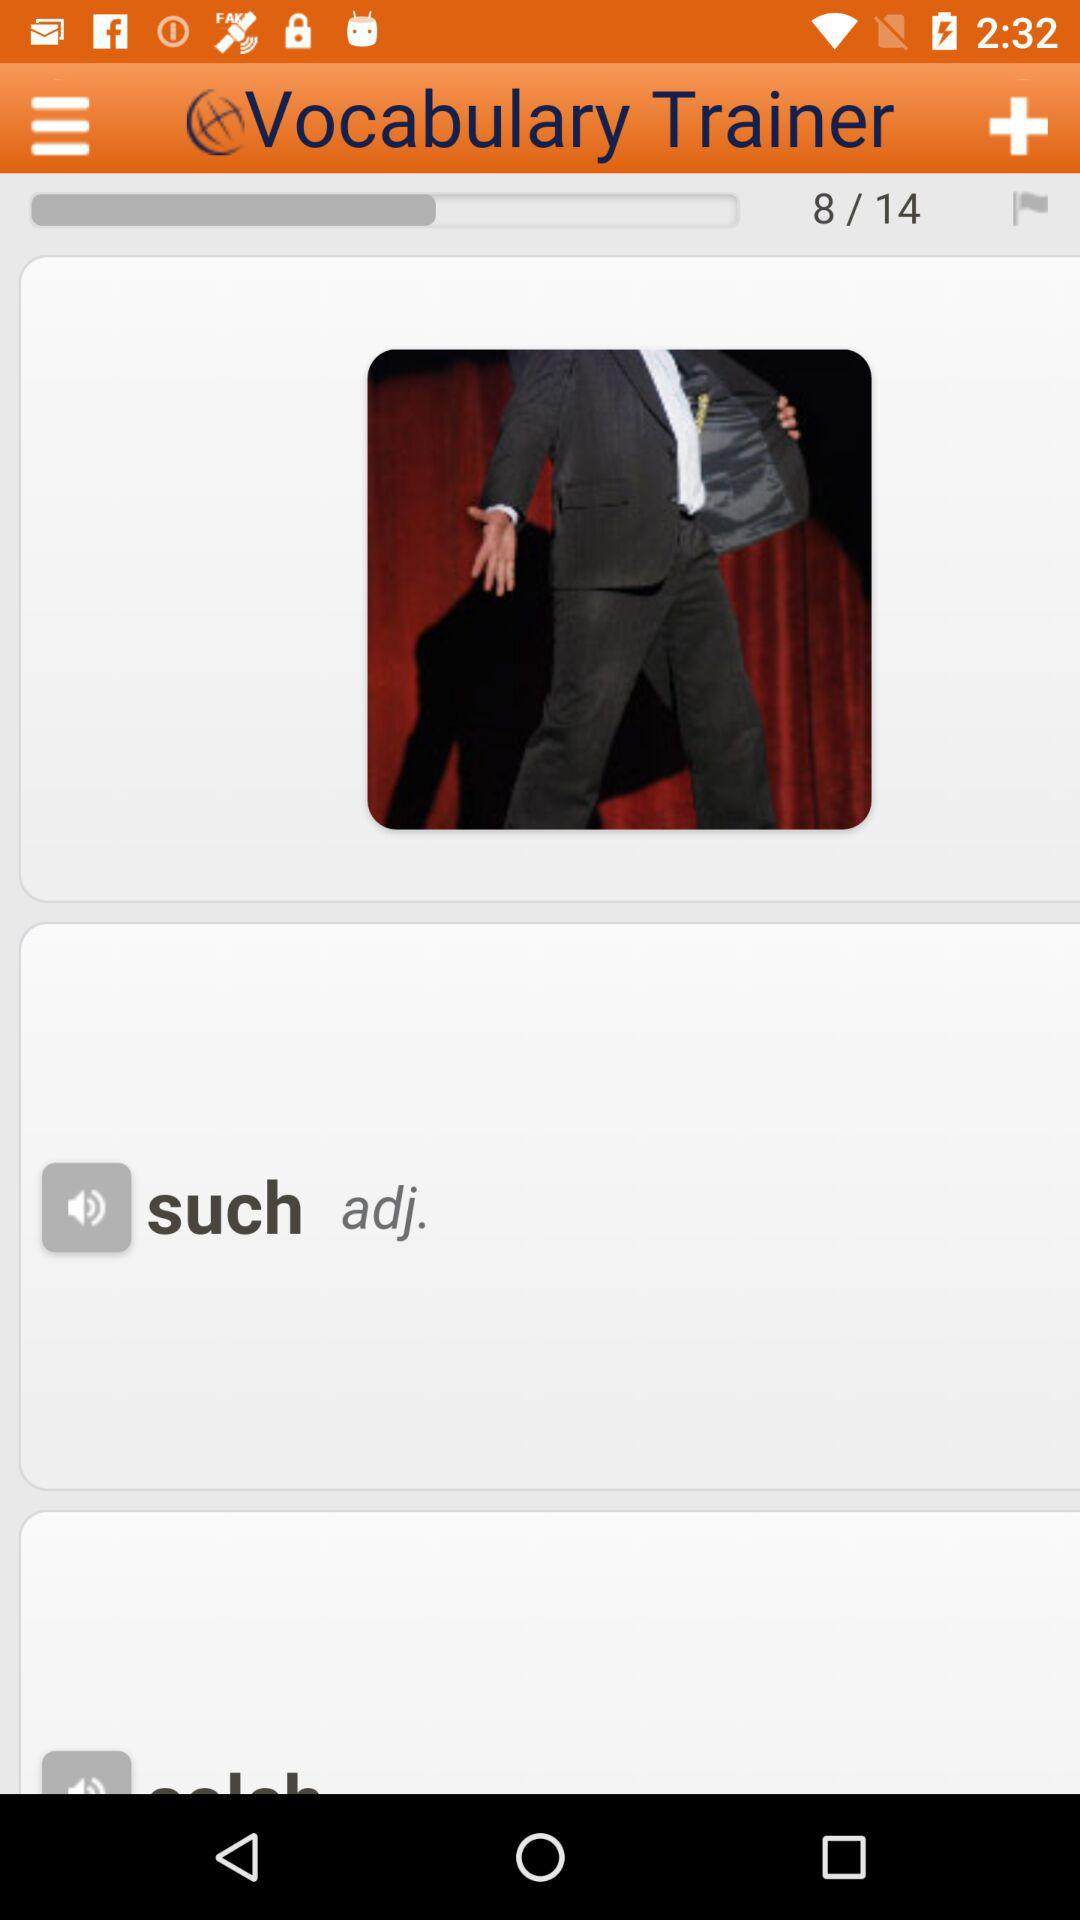What vocabulary question are we on? You are on the eighth question. 